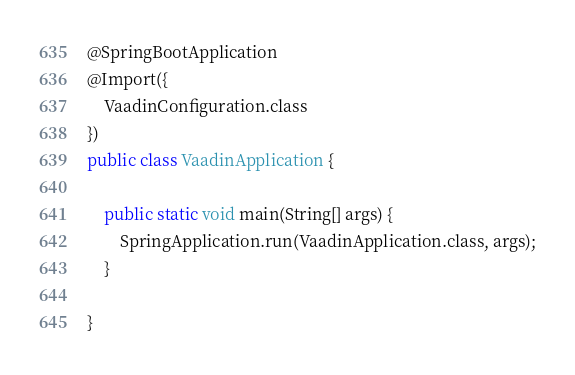Convert code to text. <code><loc_0><loc_0><loc_500><loc_500><_Java_>@SpringBootApplication
@Import({
    VaadinConfiguration.class
})
public class VaadinApplication {

	public static void main(String[] args) {
		SpringApplication.run(VaadinApplication.class, args);
	}
	
}
</code> 